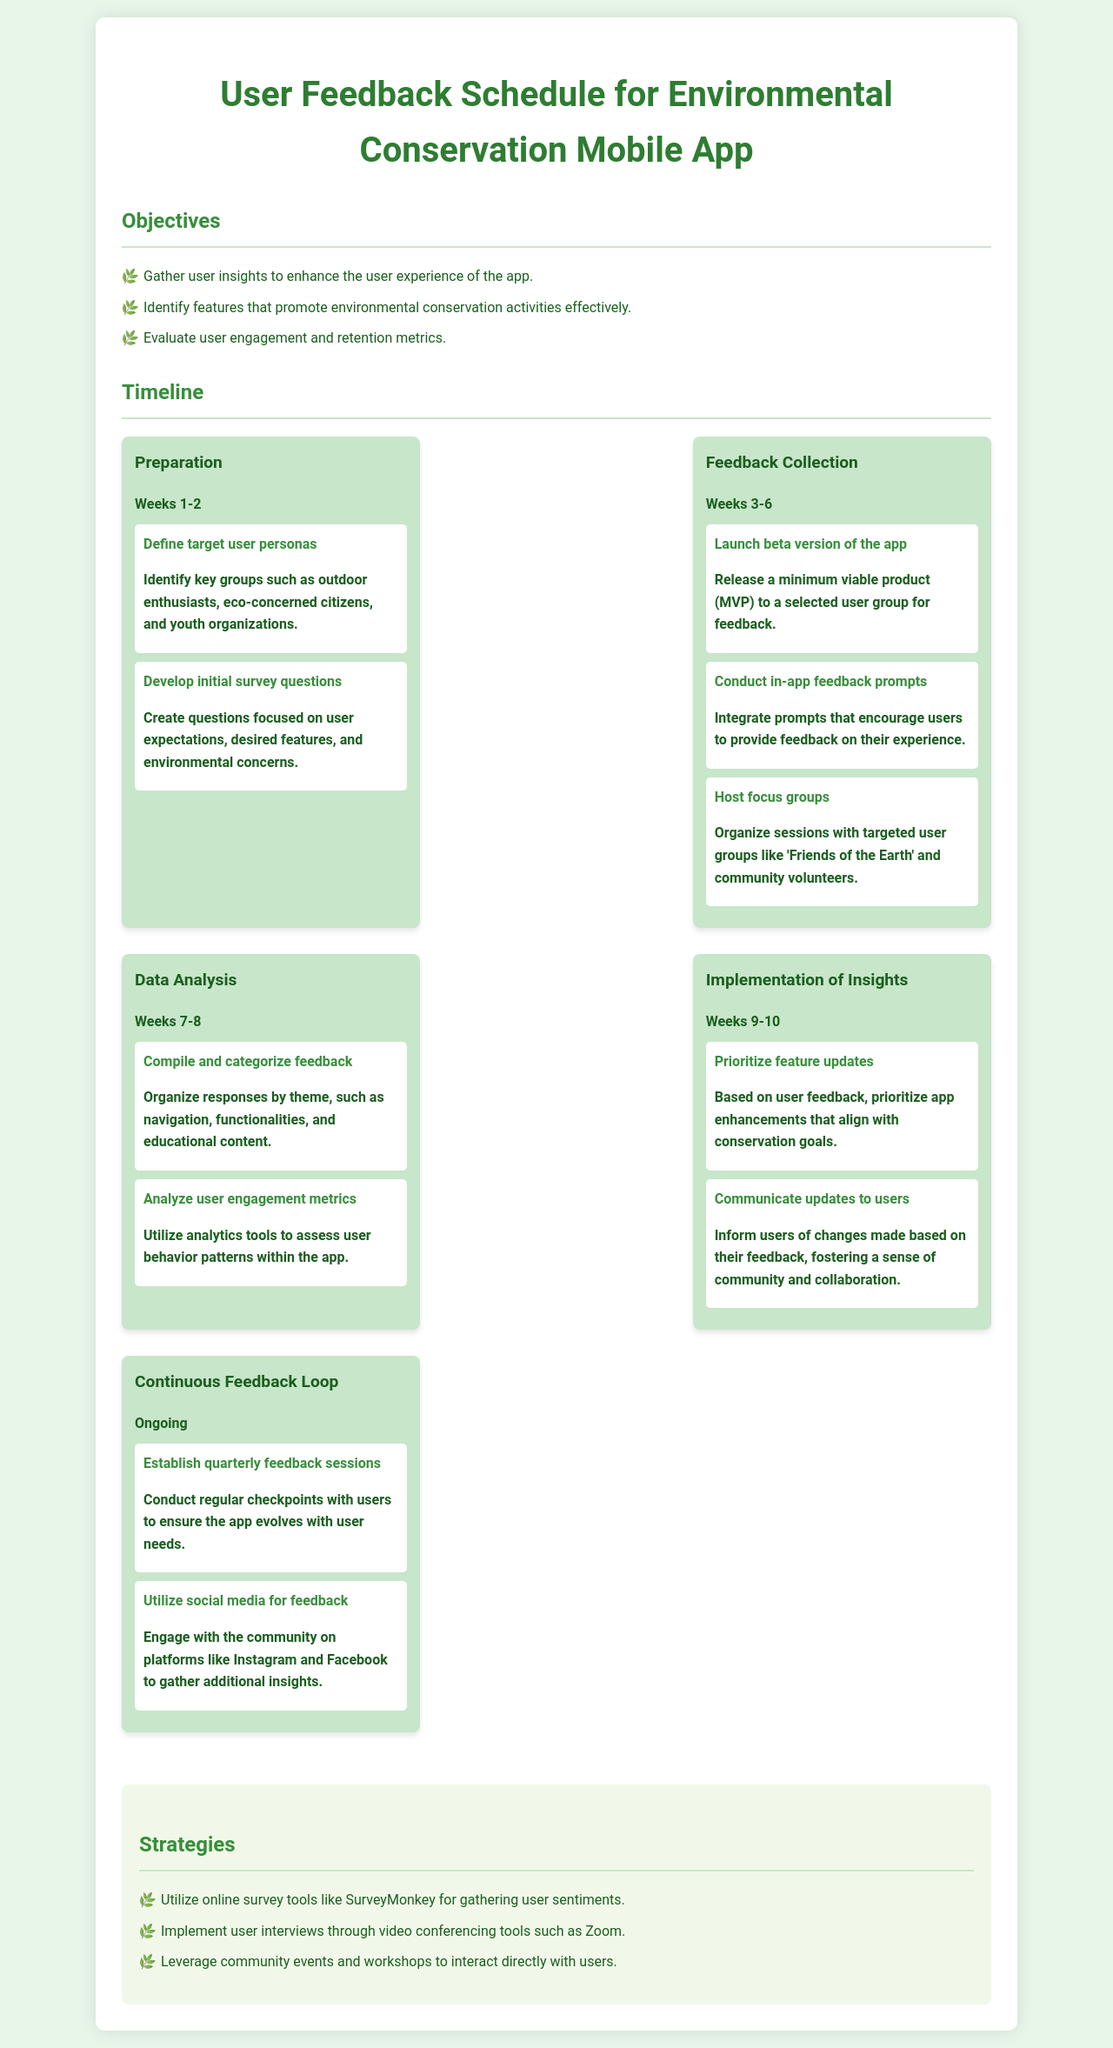What is the title of the document? The title of the document is found in the header of the schedule.
Answer: User Feedback Schedule for Environmental Conservation Mobile App Who are targeted user personas in the preparation phase? The targeted user personas are mentioned in the preparation phase activities.
Answer: Outdoor enthusiasts, eco-concerned citizens, and youth organizations How many weeks is the feedback collection phase scheduled for? The feedback collection phase spans a specific duration stated in the timeline section.
Answer: 4 weeks What activity is planned for weeks 9-10? The activities during weeks 9-10 include specific actions detailed in the implementation phase.
Answer: Prioritize feature updates Which strategy involves using social media platforms? The strategies section outlines various methods for collecting feedback, including one that mentions social media.
Answer: Utilize social media for feedback What type of tool is suggested for online surveys? The specific tool for online surveys is mentioned in the strategies section.
Answer: SurveyMonkey What is one reason for communicating updates to users? The reason for informing users of updates is provided in relation to the implementation of insights phase.
Answer: Fostering a sense of community and collaboration How often are quarterly feedback sessions planned? The frequency of feedback sessions is indicated in the continuous feedback loop section.
Answer: Quarterly 